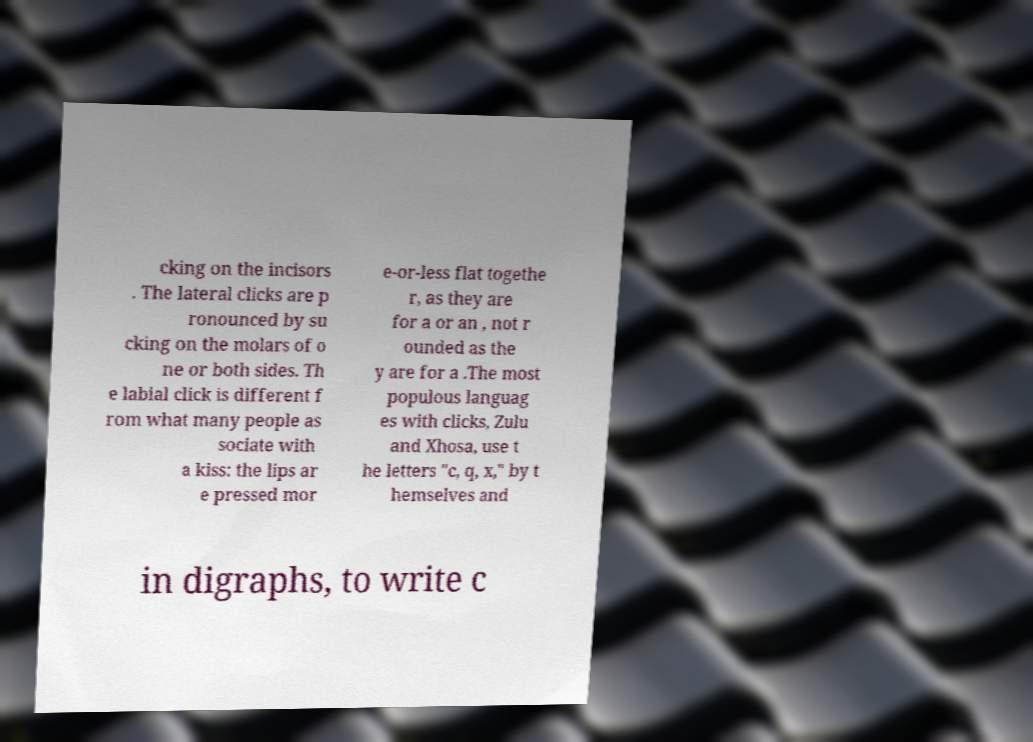I need the written content from this picture converted into text. Can you do that? cking on the incisors . The lateral clicks are p ronounced by su cking on the molars of o ne or both sides. Th e labial click is different f rom what many people as sociate with a kiss: the lips ar e pressed mor e-or-less flat togethe r, as they are for a or an , not r ounded as the y are for a .The most populous languag es with clicks, Zulu and Xhosa, use t he letters "c, q, x," by t hemselves and in digraphs, to write c 